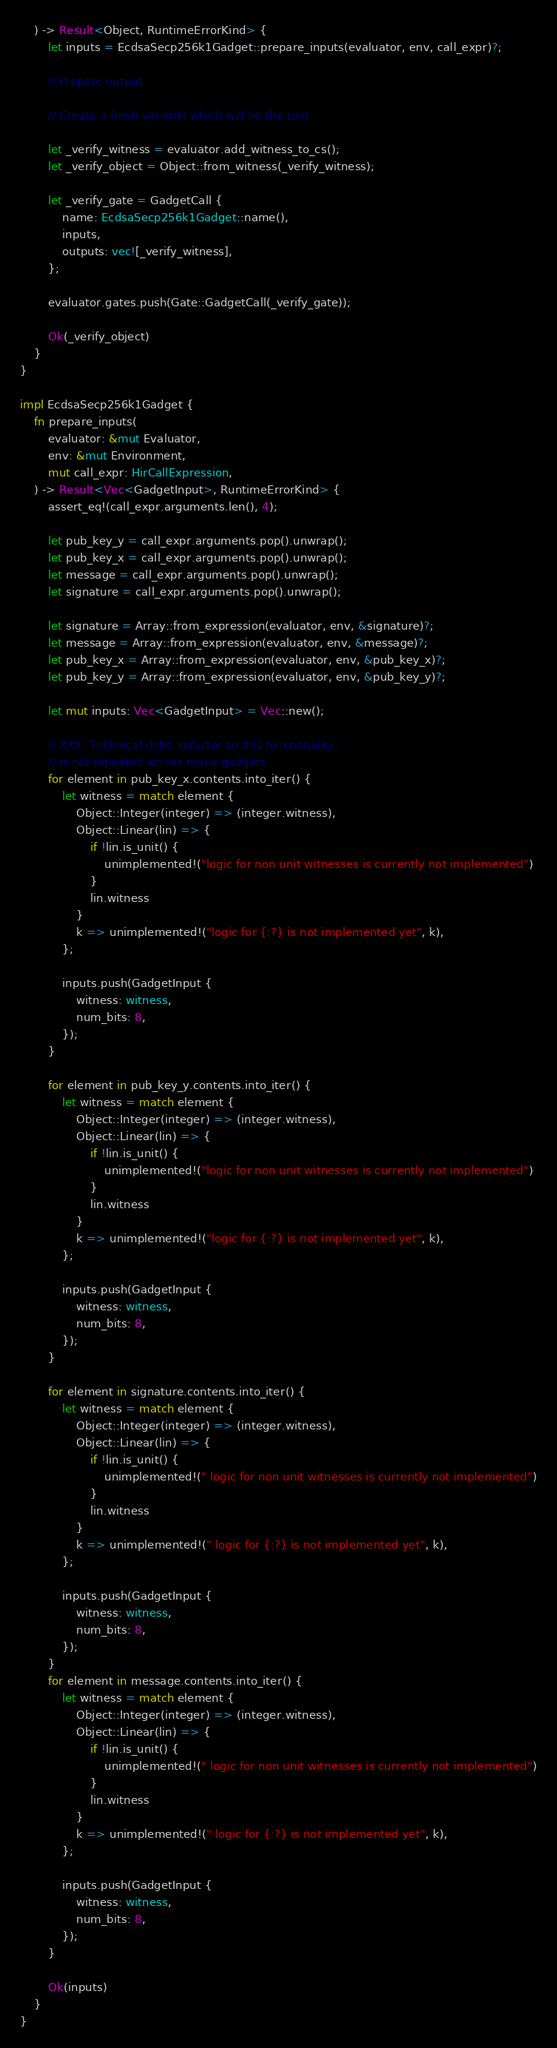<code> <loc_0><loc_0><loc_500><loc_500><_Rust_>    ) -> Result<Object, RuntimeErrorKind> {
        let inputs = EcdsaSecp256k1Gadget::prepare_inputs(evaluator, env, call_expr)?;

        // Prepare output

        // Create a fresh variable which will be the root

        let _verify_witness = evaluator.add_witness_to_cs();
        let _verify_object = Object::from_witness(_verify_witness);

        let _verify_gate = GadgetCall {
            name: EcdsaSecp256k1Gadget::name(),
            inputs,
            outputs: vec![_verify_witness],
        };

        evaluator.gates.push(Gate::GadgetCall(_verify_gate));

        Ok(_verify_object)
    }
}

impl EcdsaSecp256k1Gadget {
    fn prepare_inputs(
        evaluator: &mut Evaluator,
        env: &mut Environment,
        mut call_expr: HirCallExpression,
    ) -> Result<Vec<GadgetInput>, RuntimeErrorKind> {
        assert_eq!(call_expr.arguments.len(), 4);

        let pub_key_y = call_expr.arguments.pop().unwrap();
        let pub_key_x = call_expr.arguments.pop().unwrap();
        let message = call_expr.arguments.pop().unwrap();
        let signature = call_expr.arguments.pop().unwrap();

        let signature = Array::from_expression(evaluator, env, &signature)?;
        let message = Array::from_expression(evaluator, env, &message)?;
        let pub_key_x = Array::from_expression(evaluator, env, &pub_key_x)?;
        let pub_key_y = Array::from_expression(evaluator, env, &pub_key_y)?;

        let mut inputs: Vec<GadgetInput> = Vec::new();

        // XXX: Technical debt: refactor so this functionality,
        // is not repeated across many gadgets
        for element in pub_key_x.contents.into_iter() {
            let witness = match element {
                Object::Integer(integer) => (integer.witness),
                Object::Linear(lin) => {
                    if !lin.is_unit() {
                        unimplemented!("logic for non unit witnesses is currently not implemented")
                    }
                    lin.witness
                }
                k => unimplemented!("logic for {:?} is not implemented yet", k),
            };

            inputs.push(GadgetInput {
                witness: witness,
                num_bits: 8,
            });
        }

        for element in pub_key_y.contents.into_iter() {
            let witness = match element {
                Object::Integer(integer) => (integer.witness),
                Object::Linear(lin) => {
                    if !lin.is_unit() {
                        unimplemented!("logic for non unit witnesses is currently not implemented")
                    }
                    lin.witness
                }
                k => unimplemented!("logic for {:?} is not implemented yet", k),
            };

            inputs.push(GadgetInput {
                witness: witness,
                num_bits: 8,
            });
        }

        for element in signature.contents.into_iter() {
            let witness = match element {
                Object::Integer(integer) => (integer.witness),
                Object::Linear(lin) => {
                    if !lin.is_unit() {
                        unimplemented!(" logic for non unit witnesses is currently not implemented")
                    }
                    lin.witness
                }
                k => unimplemented!(" logic for {:?} is not implemented yet", k),
            };

            inputs.push(GadgetInput {
                witness: witness,
                num_bits: 8,
            });
        }
        for element in message.contents.into_iter() {
            let witness = match element {
                Object::Integer(integer) => (integer.witness),
                Object::Linear(lin) => {
                    if !lin.is_unit() {
                        unimplemented!(" logic for non unit witnesses is currently not implemented")
                    }
                    lin.witness
                }
                k => unimplemented!(" logic for {:?} is not implemented yet", k),
            };

            inputs.push(GadgetInput {
                witness: witness,
                num_bits: 8,
            });
        }

        Ok(inputs)
    }
}
</code> 